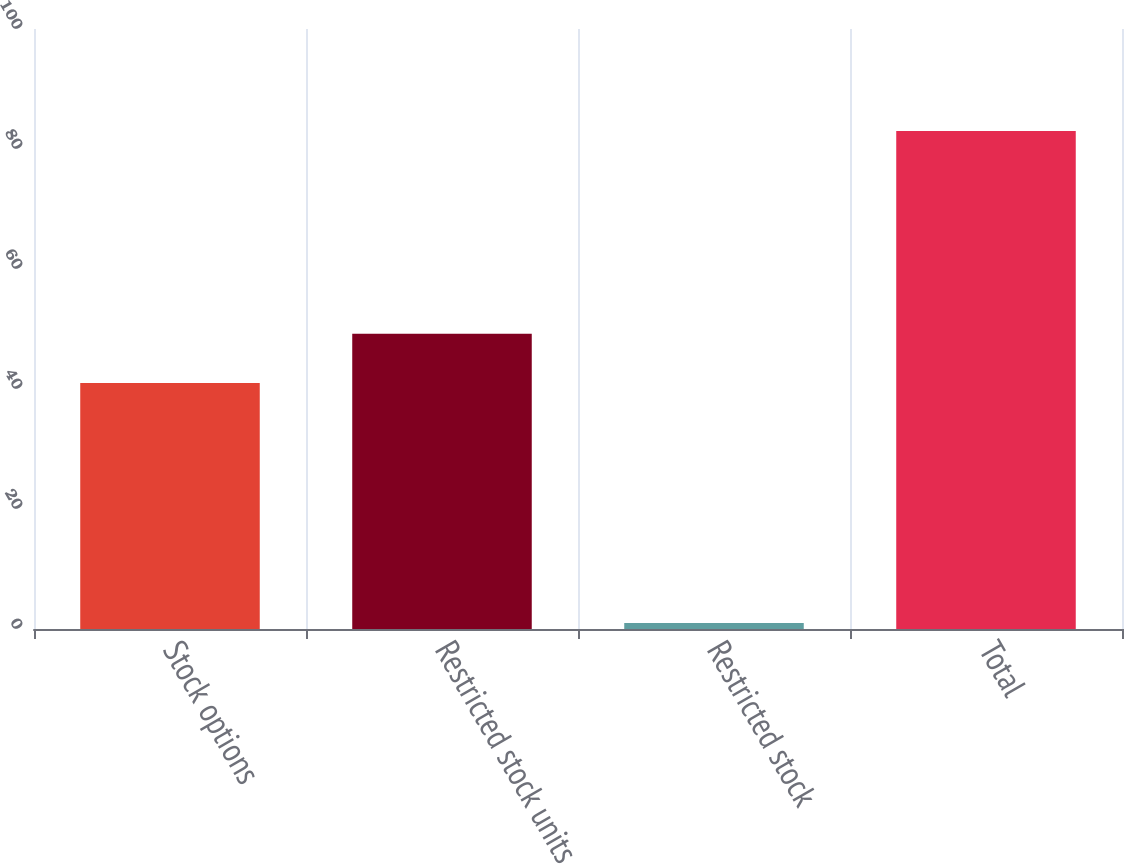Convert chart to OTSL. <chart><loc_0><loc_0><loc_500><loc_500><bar_chart><fcel>Stock options<fcel>Restricted stock units<fcel>Restricted stock<fcel>Total<nl><fcel>41<fcel>49.2<fcel>1<fcel>83<nl></chart> 